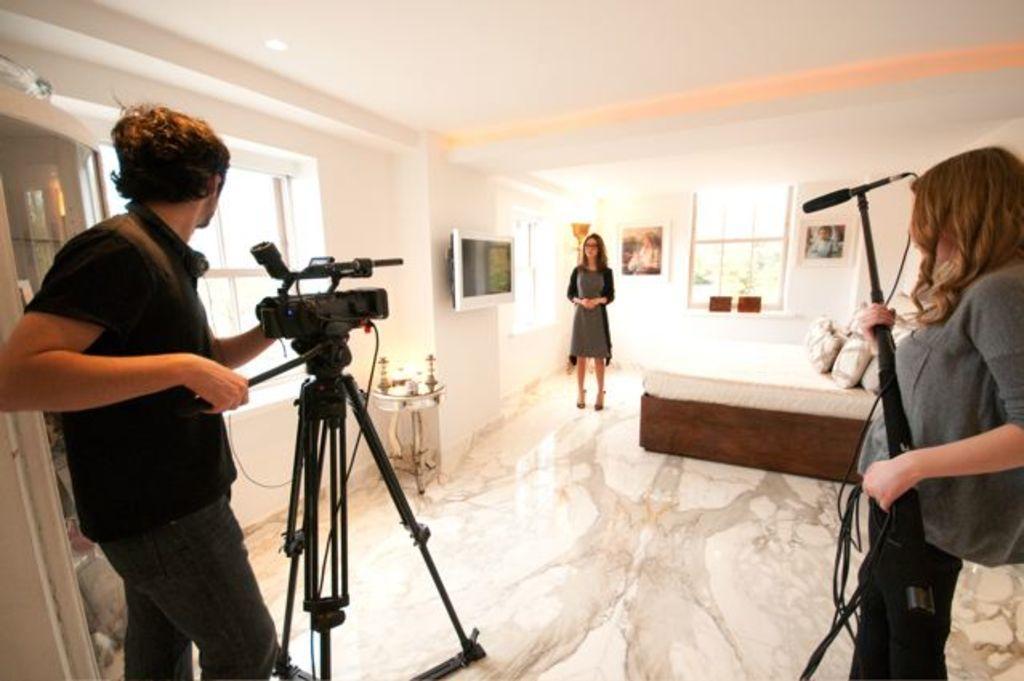In one or two sentences, can you explain what this image depicts? In the left side a man is holding the camera, he wore a black color t-shirt, in the middle a woman is standing. In the right side a woman is holding the microphone. 